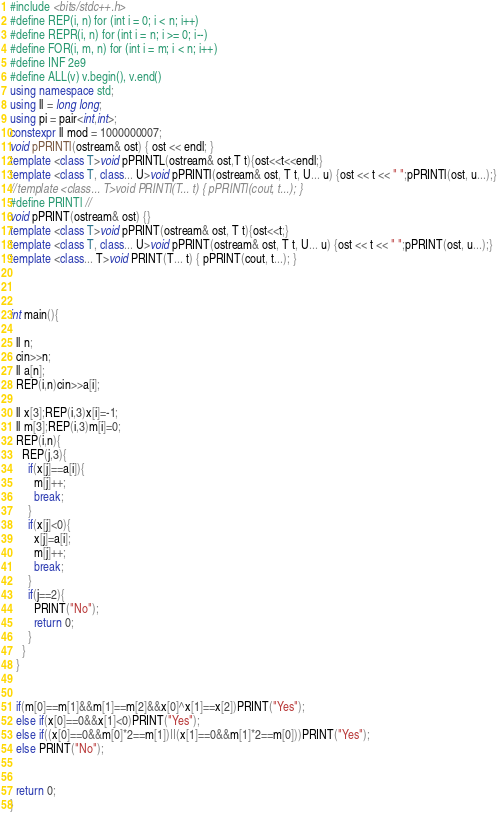<code> <loc_0><loc_0><loc_500><loc_500><_C++_>#include <bits/stdc++.h>
#define REP(i, n) for (int i = 0; i < n; i++)
#define REPR(i, n) for (int i = n; i >= 0; i--)
#define FOR(i, m, n) for (int i = m; i < n; i++)
#define INF 2e9
#define ALL(v) v.begin(), v.end()
using namespace std;
using ll = long long;
using pi = pair<int,int>;
constexpr ll mod = 1000000007;
void pPRINTl(ostream& ost) { ost << endl; }
template <class T>void pPRINTL(ostream& ost,T t){ost<<t<<endl;}
template <class T, class... U>void pPRINTl(ostream& ost, T t, U... u) {ost << t << " ";pPRINTl(ost, u...);}
//template <class... T>void PRINTl(T... t) { pPRINTl(cout, t...); }
#define PRINTl //
void pPRINT(ostream& ost) {}
template <class T>void pPRINT(ostream& ost, T t){ost<<t;}
template <class T, class... U>void pPRINT(ostream& ost, T t, U... u) {ost << t << " ";pPRINT(ost, u...);}
template <class... T>void PRINT(T... t) { pPRINT(cout, t...); }



int main(){
  
  ll n;
  cin>>n;
  ll a[n];
  REP(i,n)cin>>a[i];
  
  ll x[3];REP(i,3)x[i]=-1;
  ll m[3];REP(i,3)m[i]=0;
  REP(i,n){
    REP(j,3){
      if(x[j]==a[i]){
        m[j]++;
        break;
      }
      if(x[j]<0){
        x[j]=a[i];
        m[j]++;
        break;
      }
      if(j==2){
        PRINT("No");
        return 0;
      }
    }
  } 
  
  
  if(m[0]==m[1]&&m[1]==m[2]&&x[0]^x[1]==x[2])PRINT("Yes");
  else if(x[0]==0&&x[1]<0)PRINT("Yes");
  else if((x[0]==0&&m[0]*2==m[1])||(x[1]==0&&m[1]*2==m[0]))PRINT("Yes");
  else PRINT("No");
  
  
  return 0;
}</code> 